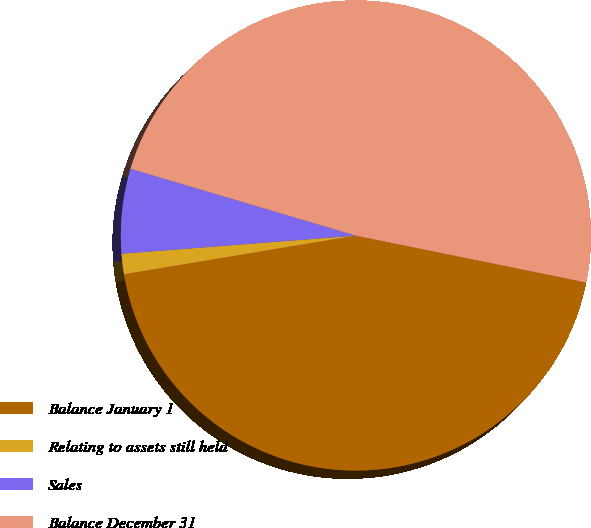<chart> <loc_0><loc_0><loc_500><loc_500><pie_chart><fcel>Balance January 1<fcel>Relating to assets still held<fcel>Sales<fcel>Balance December 31<nl><fcel>44.18%<fcel>1.4%<fcel>5.82%<fcel>48.6%<nl></chart> 